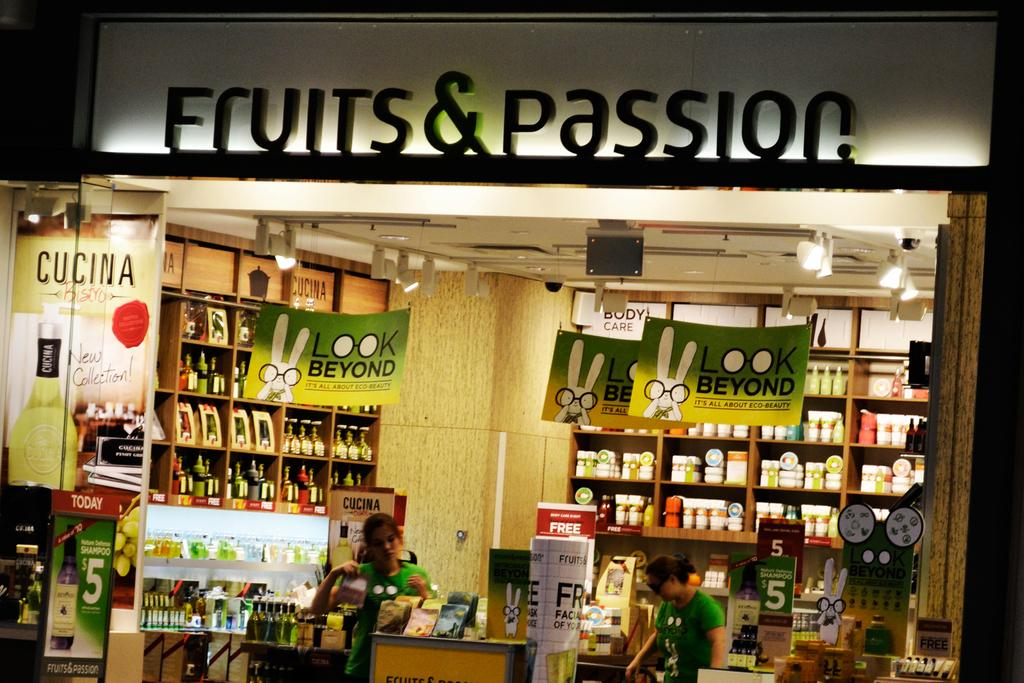<image>
Render a clear and concise summary of the photo. The store front of fruits & passion with 2 workers inside. 